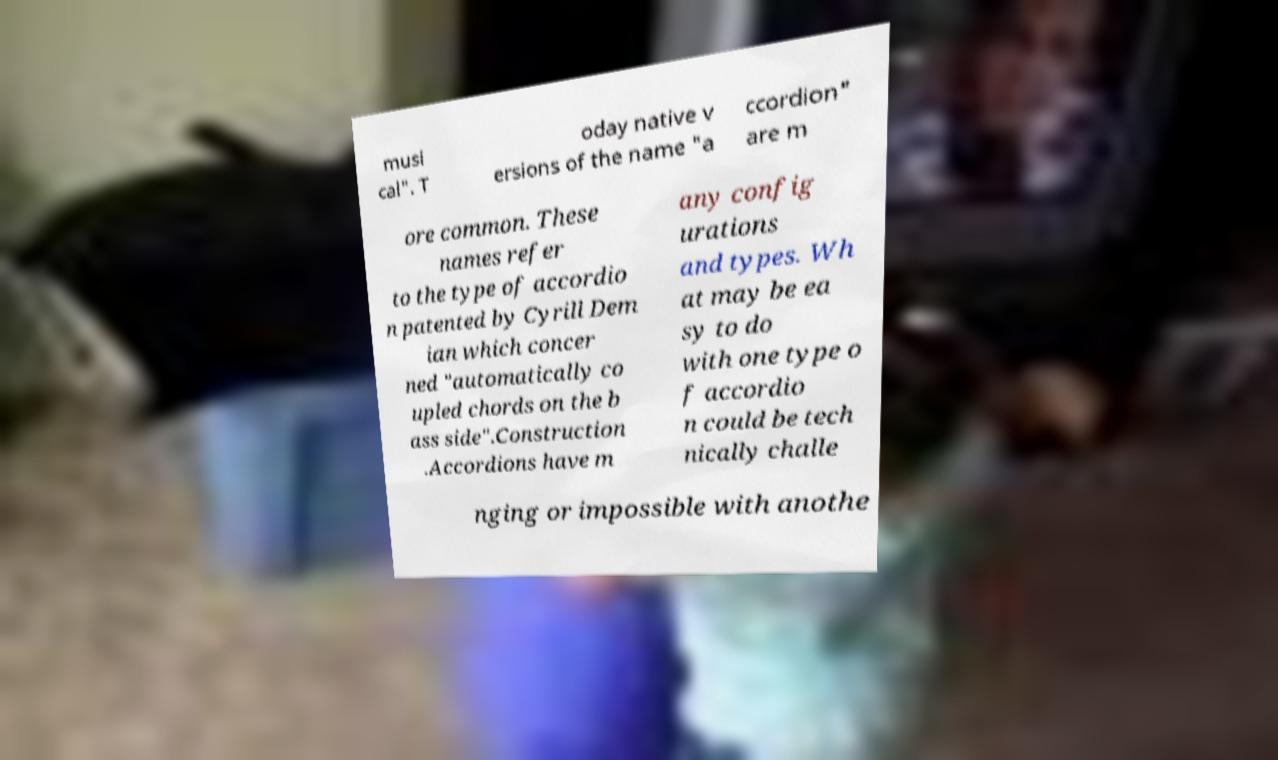There's text embedded in this image that I need extracted. Can you transcribe it verbatim? musi cal". T oday native v ersions of the name "a ccordion" are m ore common. These names refer to the type of accordio n patented by Cyrill Dem ian which concer ned "automatically co upled chords on the b ass side".Construction .Accordions have m any config urations and types. Wh at may be ea sy to do with one type o f accordio n could be tech nically challe nging or impossible with anothe 